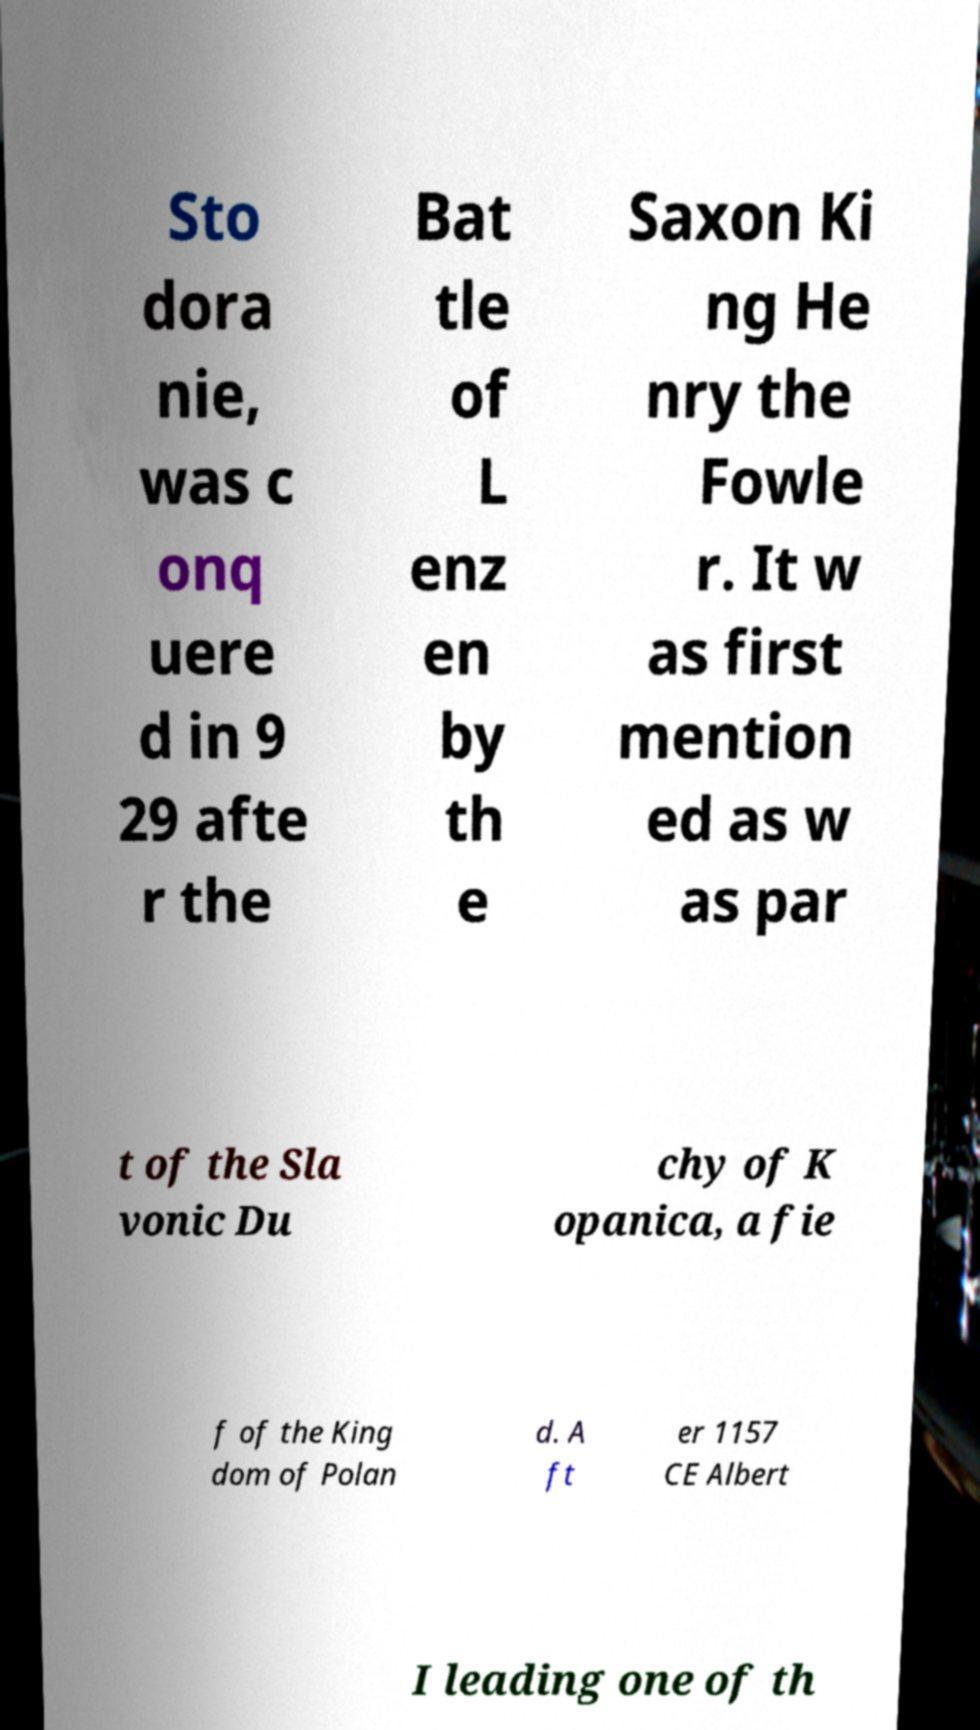Can you accurately transcribe the text from the provided image for me? Sto dora nie, was c onq uere d in 9 29 afte r the Bat tle of L enz en by th e Saxon Ki ng He nry the Fowle r. It w as first mention ed as w as par t of the Sla vonic Du chy of K opanica, a fie f of the King dom of Polan d. A ft er 1157 CE Albert I leading one of th 